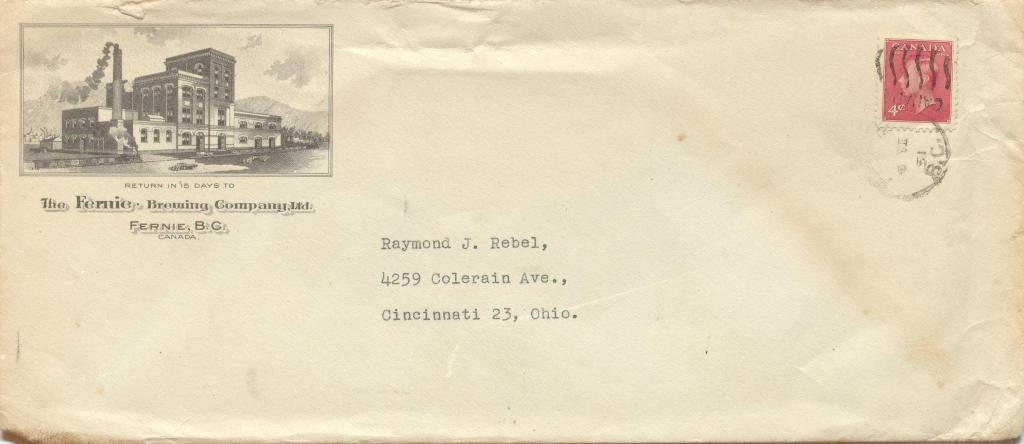<image>
Present a compact description of the photo's key features. Envelope address to Raymond J. Rebel with a picture of a building on the corner. 